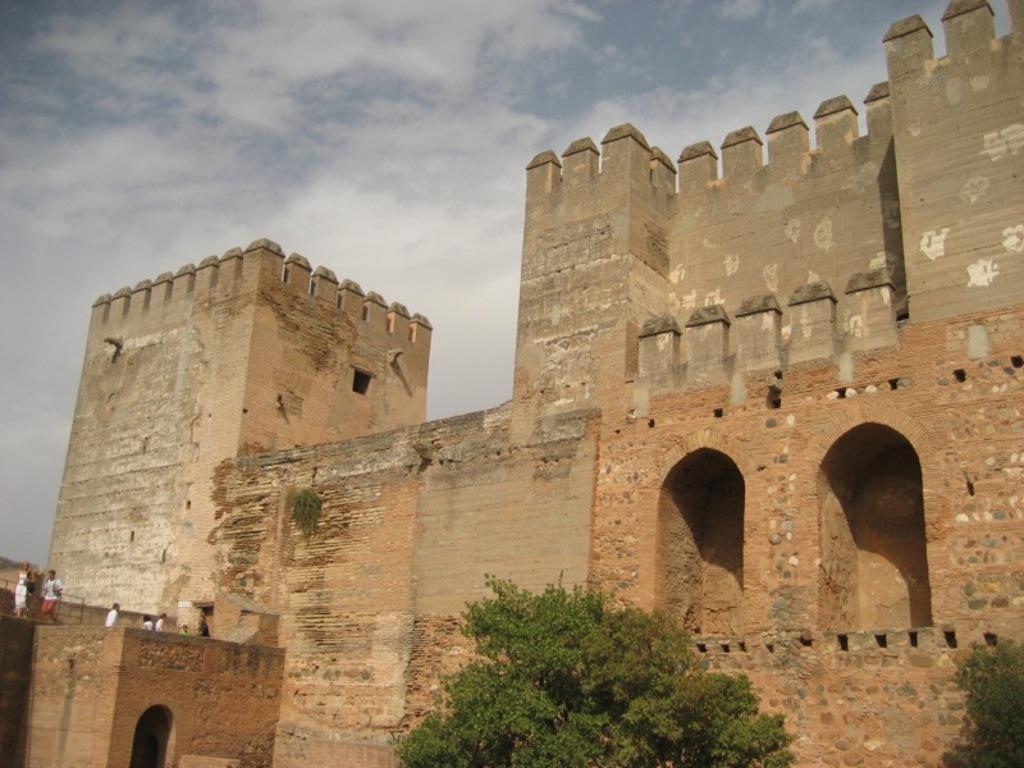Can you describe this image briefly? In this image I can see few trees which are green in color, a fort which is brown and grey in color and few persons standing on the fort. In the background I can see the sky. 